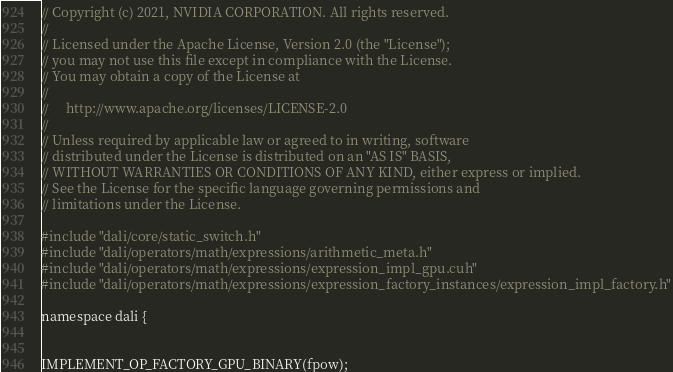Convert code to text. <code><loc_0><loc_0><loc_500><loc_500><_Cuda_>// Copyright (c) 2021, NVIDIA CORPORATION. All rights reserved.
//
// Licensed under the Apache License, Version 2.0 (the "License");
// you may not use this file except in compliance with the License.
// You may obtain a copy of the License at
//
//     http://www.apache.org/licenses/LICENSE-2.0
//
// Unless required by applicable law or agreed to in writing, software
// distributed under the License is distributed on an "AS IS" BASIS,
// WITHOUT WARRANTIES OR CONDITIONS OF ANY KIND, either express or implied.
// See the License for the specific language governing permissions and
// limitations under the License.

#include "dali/core/static_switch.h"
#include "dali/operators/math/expressions/arithmetic_meta.h"
#include "dali/operators/math/expressions/expression_impl_gpu.cuh"
#include "dali/operators/math/expressions/expression_factory_instances/expression_impl_factory.h"

namespace dali {


IMPLEMENT_OP_FACTORY_GPU_BINARY(fpow);

</code> 